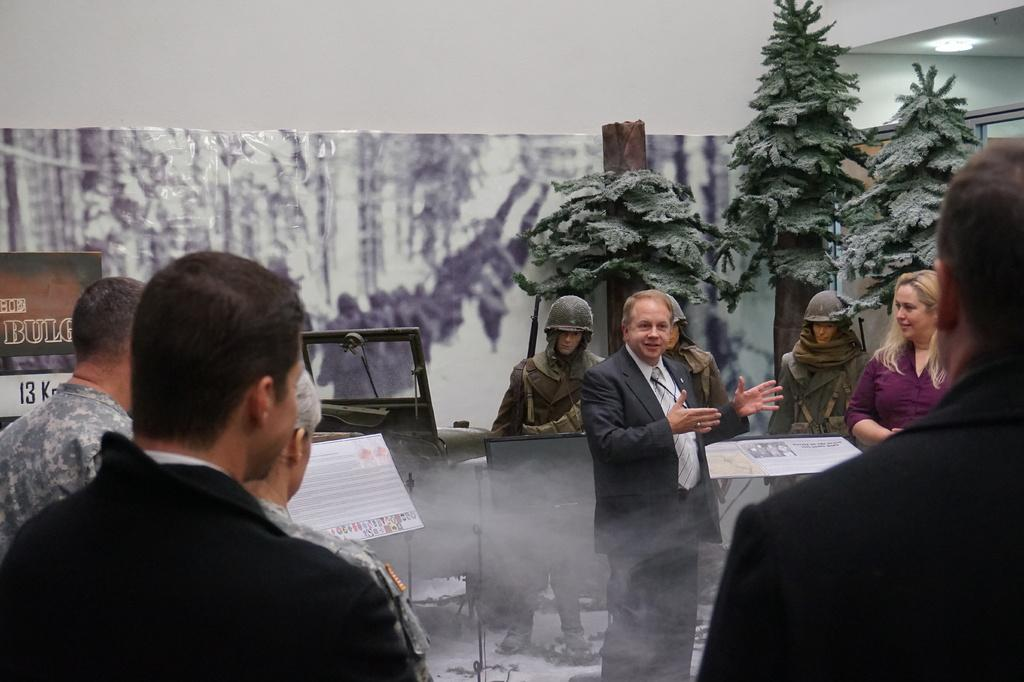How many people are in the image? There is a group of persons in the image. What can be seen in the background of the image? There are three statues and trees in the background of the image. What type of wine is being served to the friend in the image? There is no wine or friend present in the image. 